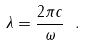Convert formula to latex. <formula><loc_0><loc_0><loc_500><loc_500>\lambda = \frac { 2 \pi c } { \omega } \ .</formula> 